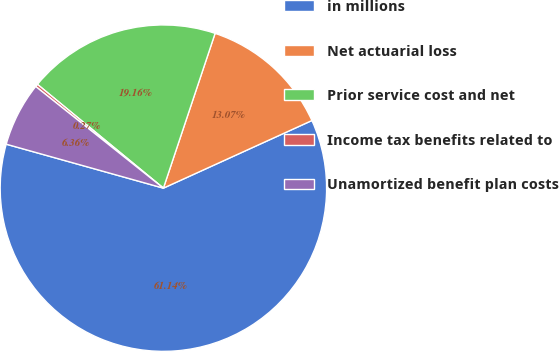<chart> <loc_0><loc_0><loc_500><loc_500><pie_chart><fcel>in millions<fcel>Net actuarial loss<fcel>Prior service cost and net<fcel>Income tax benefits related to<fcel>Unamortized benefit plan costs<nl><fcel>61.14%<fcel>13.07%<fcel>19.16%<fcel>0.27%<fcel>6.36%<nl></chart> 